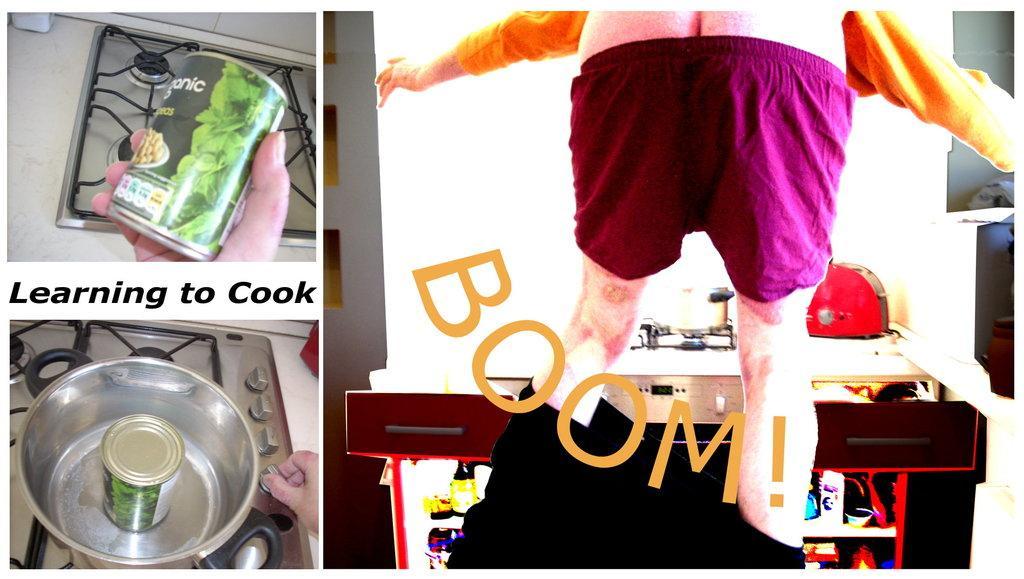In one or two sentences, can you explain what this image depicts? This image contains the collage of pictures. Left top a person's hand is visible. He is holding a coke can. Behind there is a stove. Left bottom there is a bowl having a coke can. The bowl is kept on the stove. Right side a person is standing. Before him there are objects on the table. Left side there is some text. 